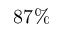<formula> <loc_0><loc_0><loc_500><loc_500>8 7 \%</formula> 